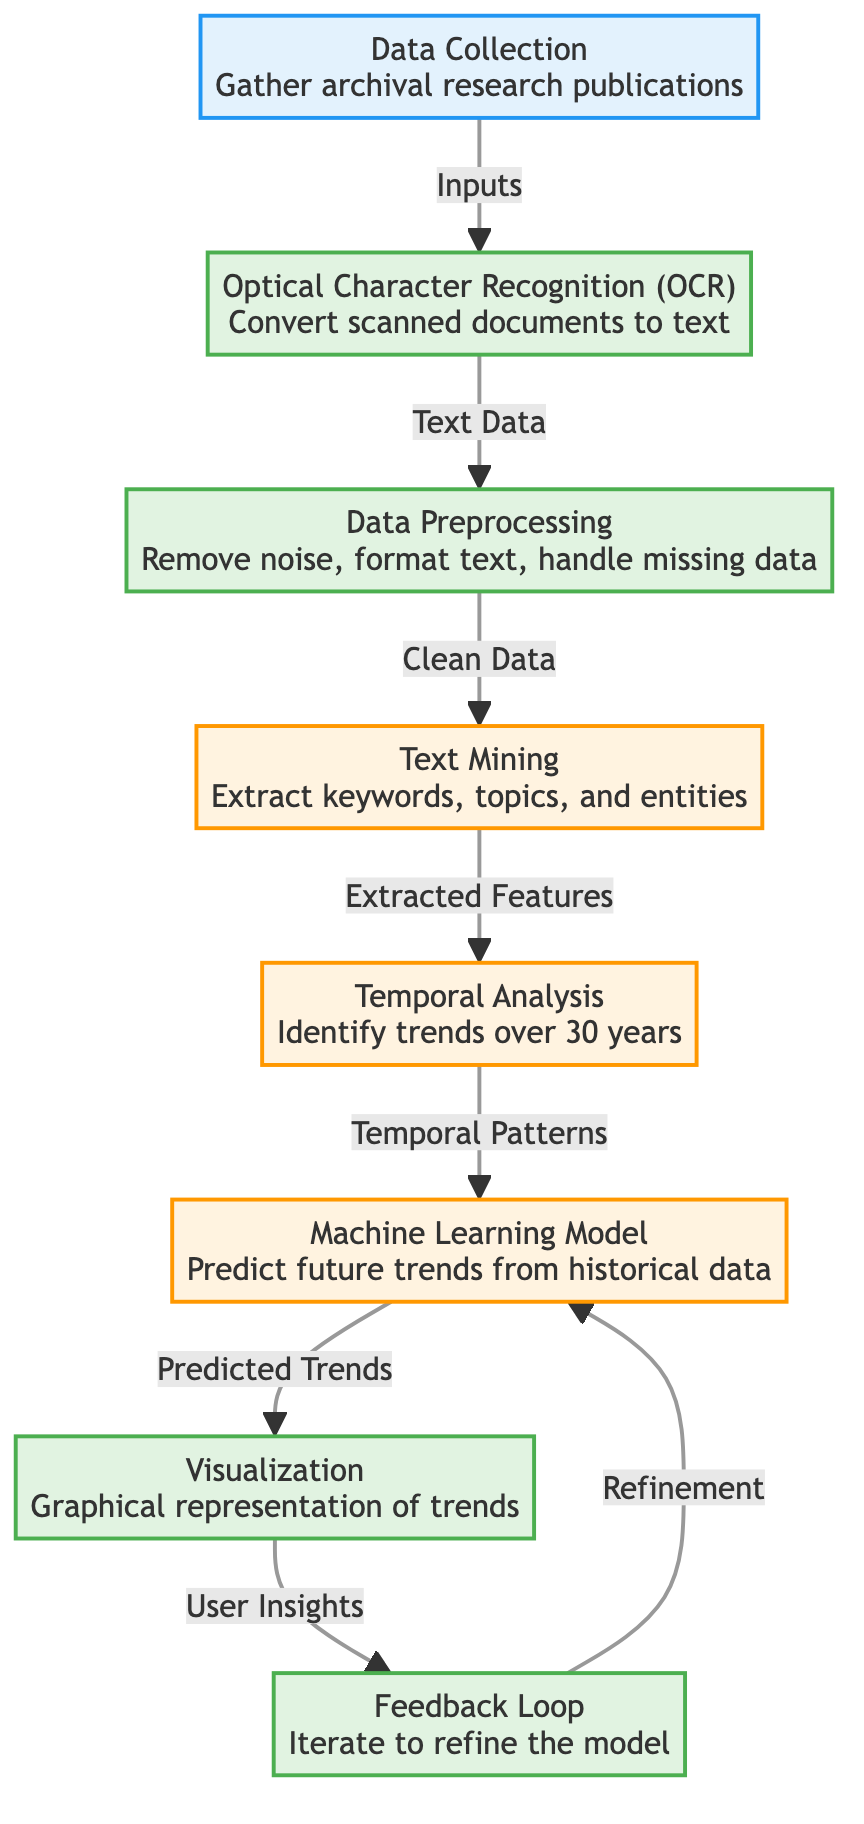What is the first step in the process? The diagram starts at the Data Collection node, indicating that the initial step is gathering archival research publications.
Answer: Data Collection How many main processes are outlined in the diagram? By counting the various nodes classified under the 'process' category, there are three main processes: Optical Character Recognition, Data Preprocessing, and Visualization.
Answer: Three What does the Temporal Analysis node output? The Temporal Analysis node is indicated to produce temporal patterns which are then used as the input for the Machine Learning Model.
Answer: Temporal Patterns Which node directly receives input from Text Mining? From the diagram, it is evident that Temporal Analysis is the node that directly follows Text Mining, indicating it receives extracted features as input.
Answer: Temporal Analysis What is the final output of the process represented in the diagram? The last node outlined in the diagram is the Visualization node, which represents graphical insights derived from predicted trends.
Answer: Visualization How does the Feedback Loop interact with the Machine Learning Model? The diagram shows that the Feedback Loop provides refinement input back into the Machine Learning Model, indicating a cyclical improvement process.
Answer: Refinement What type of analysis is represented in the diagram related to trends? The diagram categorizes the Temporal Analysis under the analysis classification, emphasizing its role in identifying trends over time.
Answer: Temporal Analysis Which process node deals with document formatting? The Data Preprocessing node is responsible for formatting text, handling missing data, and removing any noise in the data set.
Answer: Data Preprocessing How many edges connect the Data Collection node to subsequent nodes? The Data Collection node has one directed edge leading to the Optical Character Recognition node, indicating it connects to just one subsequent process.
Answer: One 